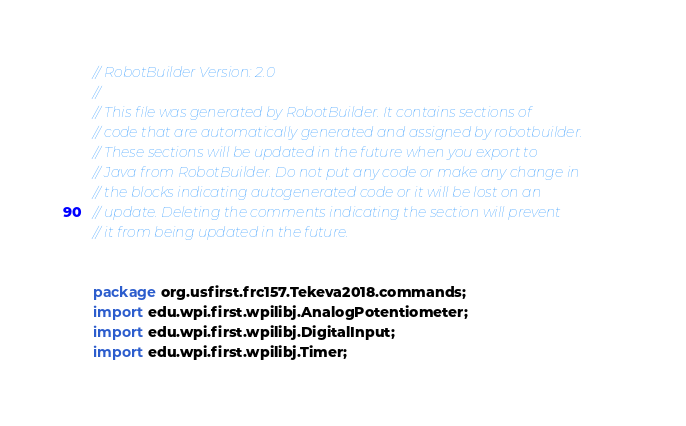Convert code to text. <code><loc_0><loc_0><loc_500><loc_500><_Java_>// RobotBuilder Version: 2.0
//
// This file was generated by RobotBuilder. It contains sections of
// code that are automatically generated and assigned by robotbuilder.
// These sections will be updated in the future when you export to
// Java from RobotBuilder. Do not put any code or make any change in
// the blocks indicating autogenerated code or it will be lost on an
// update. Deleting the comments indicating the section will prevent
// it from being updated in the future.


package org.usfirst.frc157.Tekeva2018.commands;
import edu.wpi.first.wpilibj.AnalogPotentiometer;  
import edu.wpi.first.wpilibj.DigitalInput;
import edu.wpi.first.wpilibj.Timer;</code> 